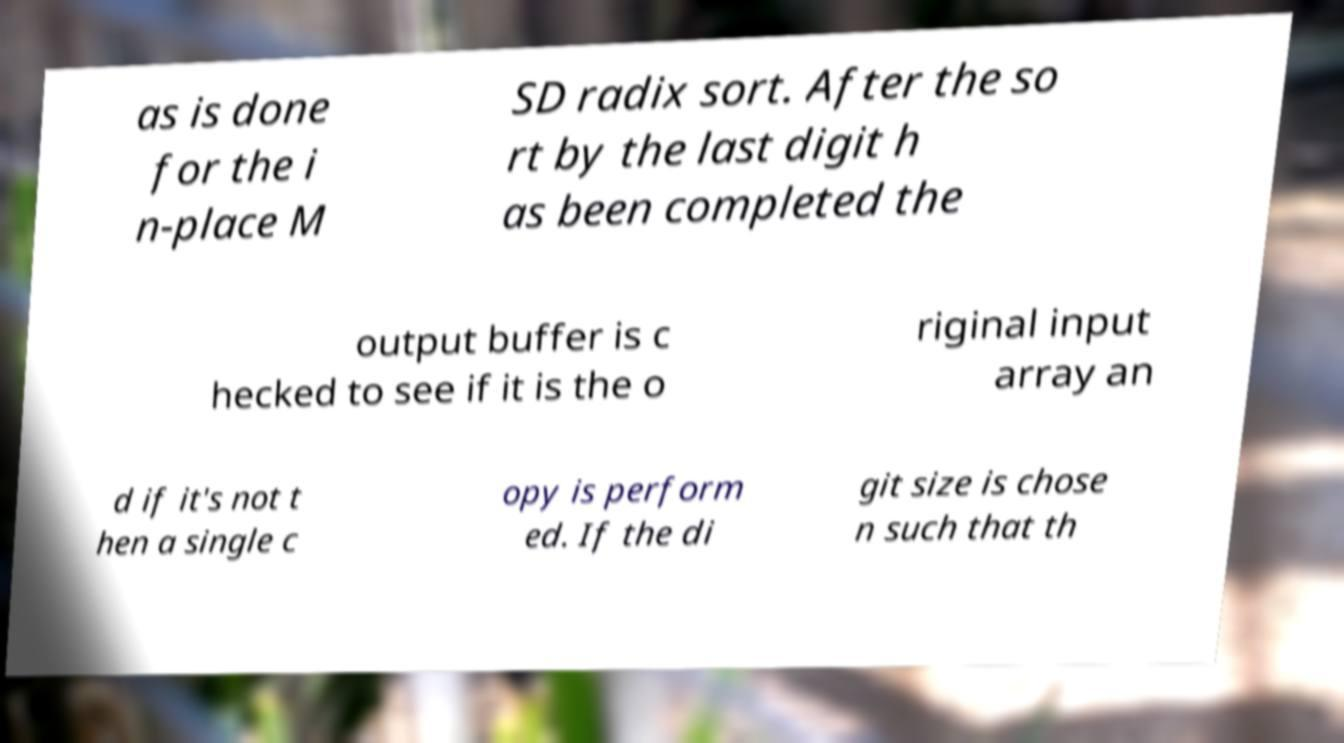What messages or text are displayed in this image? I need them in a readable, typed format. as is done for the i n-place M SD radix sort. After the so rt by the last digit h as been completed the output buffer is c hecked to see if it is the o riginal input array an d if it's not t hen a single c opy is perform ed. If the di git size is chose n such that th 